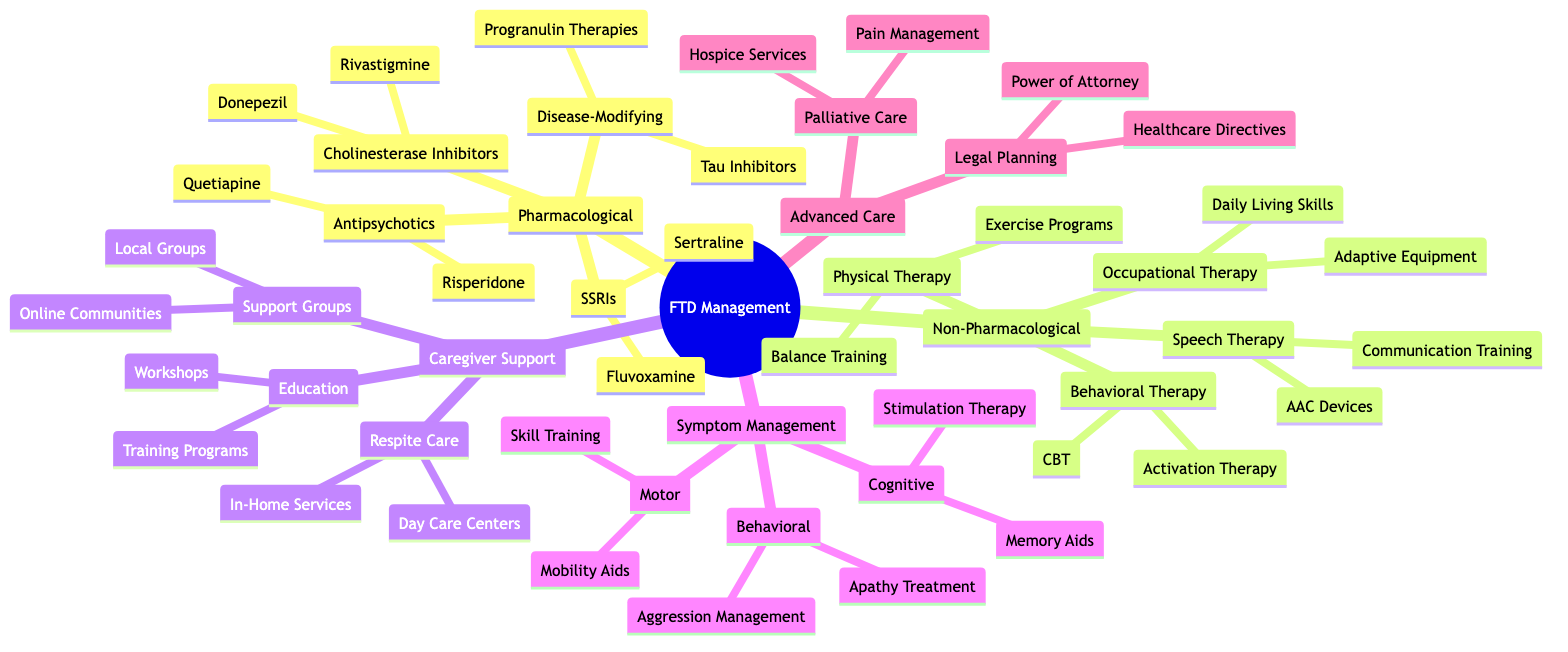What are two examples of SSRIs listed in the diagram? The diagram includes a node for SSRIs under the Pharmacological Treatments section. Two examples provided under this node are "Sertraline" and "Fluvoxamine."
Answer: Sertraline, Fluvoxamine How many types of therapies are listed under Non-Pharmacological Interventions? The Non-Pharmacological Interventions section includes four types of therapies: Behavioral Therapy, Speech and Language Therapy, Occupational Therapy, and Physical Therapy. Thus, there are four types.
Answer: 4 What are the two components of Advanced Care Planning in the diagram? The Advanced Care Planning section is divided into two components: "Legal and Financial Planning" and "Palliative Care." These can be found as immediate sub-nodes under Advanced Care Planning.
Answer: Legal and Financial Planning, Palliative Care Which category includes treatments for aggression management? The treatments for aggression management fall under the Symptom Management category, specifically within the Behavioral Symptoms sub-node. This categorization shows its relation to managing symptomatic behaviors.
Answer: Symptom Management What type of support is provided under Caregiver Support that includes community interaction? The community interaction is provided through Support Groups, which is one of the main divisions in the Caregiver Support section discussed in the diagram.
Answer: Support Groups Name one potential disease-modifying therapy mentioned in the diagram. The diagram specifies "Tau Aggregation Inhibitors" and "Progranulin Enhancement Therapies" as examples under the Potential Disease-Modifying Therapies node. Any of these can be cited as an example.
Answer: Tau Aggregation Inhibitors How many medications are suggested as Antipsychotic Medications? The Antipsychotic Medications category lists two specific medications: "Quetiapine" and "Risperidone." Therefore, there are two medications mentioned.
Answer: 2 What specific aspect does Occupational Therapy focus on? Occupational Therapy in the diagram emphasizes "Daily Living Skills Training" and "Adaptive Equipment Training," both of which are under its node. This indicates a focus on practical skills for daily living.
Answer: Daily Living Skills Training, Adaptive Equipment Training 